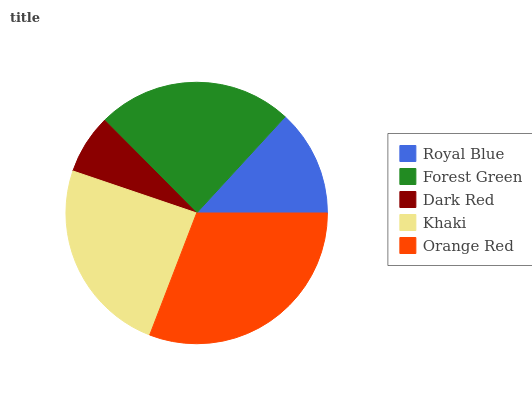Is Dark Red the minimum?
Answer yes or no. Yes. Is Orange Red the maximum?
Answer yes or no. Yes. Is Forest Green the minimum?
Answer yes or no. No. Is Forest Green the maximum?
Answer yes or no. No. Is Forest Green greater than Royal Blue?
Answer yes or no. Yes. Is Royal Blue less than Forest Green?
Answer yes or no. Yes. Is Royal Blue greater than Forest Green?
Answer yes or no. No. Is Forest Green less than Royal Blue?
Answer yes or no. No. Is Forest Green the high median?
Answer yes or no. Yes. Is Forest Green the low median?
Answer yes or no. Yes. Is Royal Blue the high median?
Answer yes or no. No. Is Dark Red the low median?
Answer yes or no. No. 